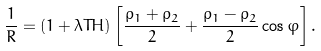Convert formula to latex. <formula><loc_0><loc_0><loc_500><loc_500>\frac { 1 } { R } = ( 1 + \lambda T H ) \left [ \frac { \rho _ { 1 } + \rho _ { 2 } } { 2 } + \frac { \rho _ { 1 } - \rho _ { 2 } } { 2 } \cos \varphi \right ] .</formula> 